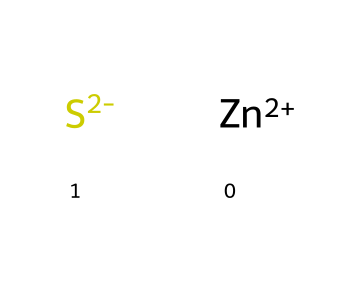What is the total number of atoms in the chemical? The chemical contains two components: one zinc ion (Zn) and one sulfide ion (S2-), which together account for three atoms (1 Zn + 1 S from S2-).
Answer: three What charge does the zinc ion carry? The zinc ion is noted as Zn+2 in the chemical, indicating it has a +2 charge.
Answer: +2 What type of bond is likely formed between zinc and sulfide in this compound? Based on the charges, a bond would be ionic, as zinc (cation) interacts with sulfide (anion) due to opposite charges.
Answer: ionic What is the significance of sulfide in phosphors? Sulfide plays a crucial role as it can provide a lattice for luminescent properties in phosphor compounds, enhancing light emissions.
Answer: luminescent properties How many distinct elements are present in this chemical? There are two distinct elements: zinc (Zn) and sulfur (S) from the sulfide ion, thus the answer is two.
Answer: two What type of chemical reaction can this compound be involved in with light? Phosphors can undergo photoluminescence, where the presence of light can excite electrons, leading to light emission when they return to their ground state.
Answer: photoluminescence 